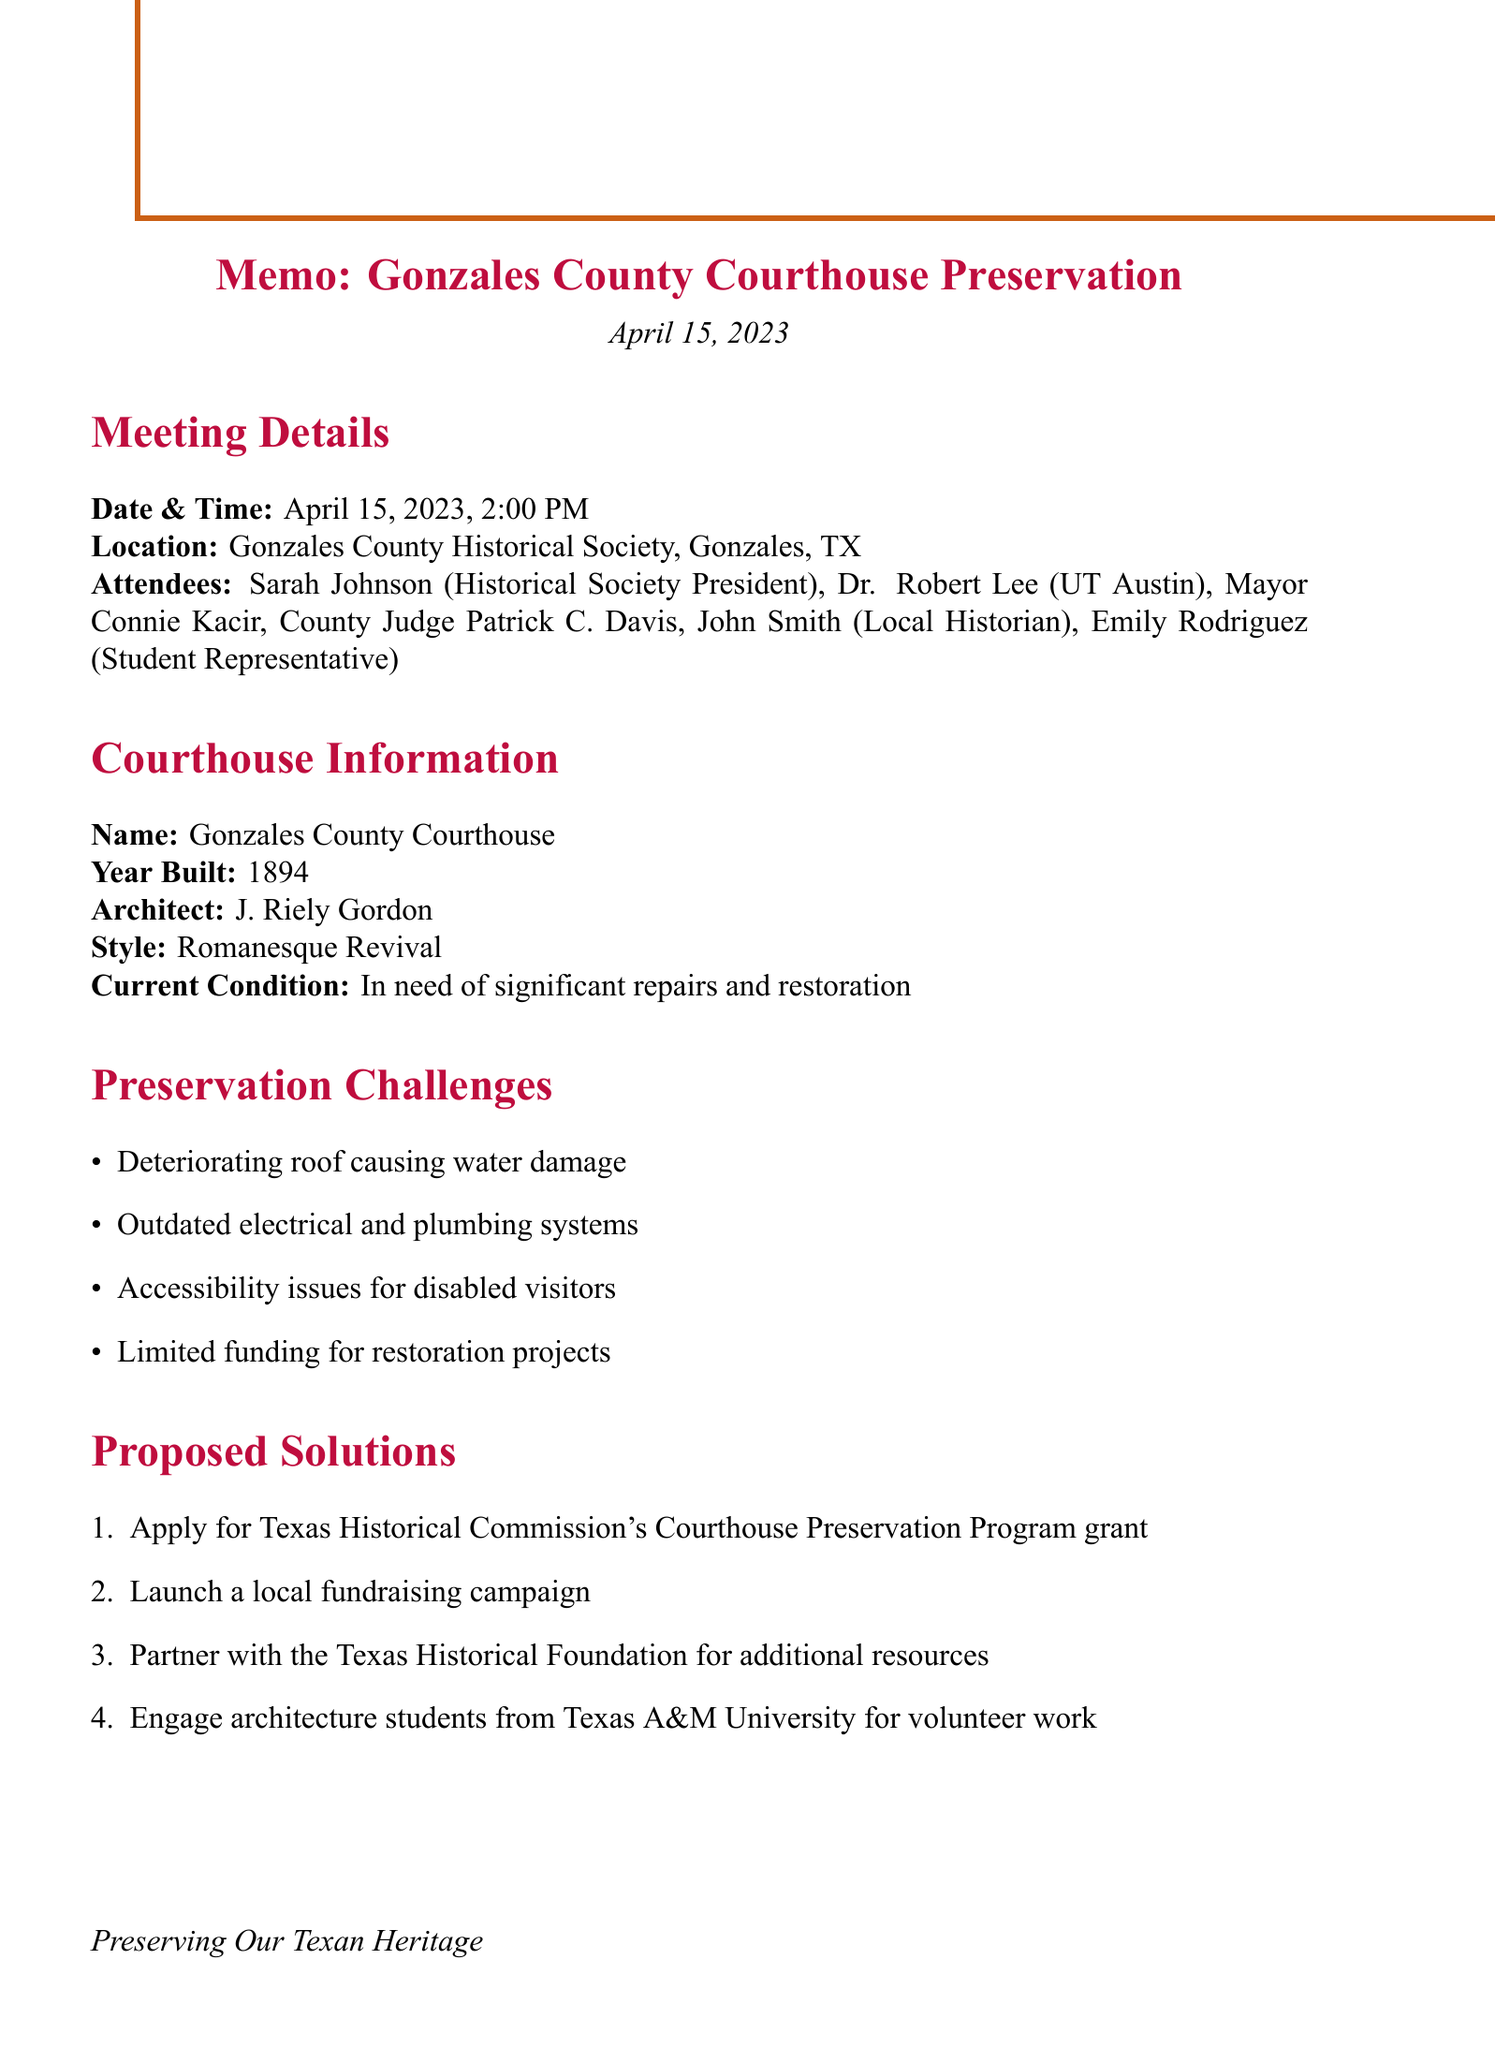What is the date of the meeting? The date of the meeting is clearly stated in the document as April 15, 2023.
Answer: April 15, 2023 Who is the architect of the Gonzales County Courthouse? The document specifies that the architect of the courthouse is J. Riely Gordon.
Answer: J. Riely Gordon What is one of the preservation challenges mentioned? The document lists several challenges, one of which is "Deteriorating roof causing water damage."
Answer: Deteriorating roof causing water damage What funding strategy is proposed? The document outlines a proposed strategy to "Launch a local fundraising campaign."
Answer: Launch a local fundraising campaign What is the historical significance of the courthouse mentioned in the document? The document states that it is "One of the few remaining examples of J. Riely Gordon's courthouse designs in Texas."
Answer: One of the few remaining examples of J. Riely Gordon's courthouse designs in Texas Who is the Student Representative at the meeting? The document identifies Emily Rodriguez as the Student Representative.
Answer: Emily Rodriguez 